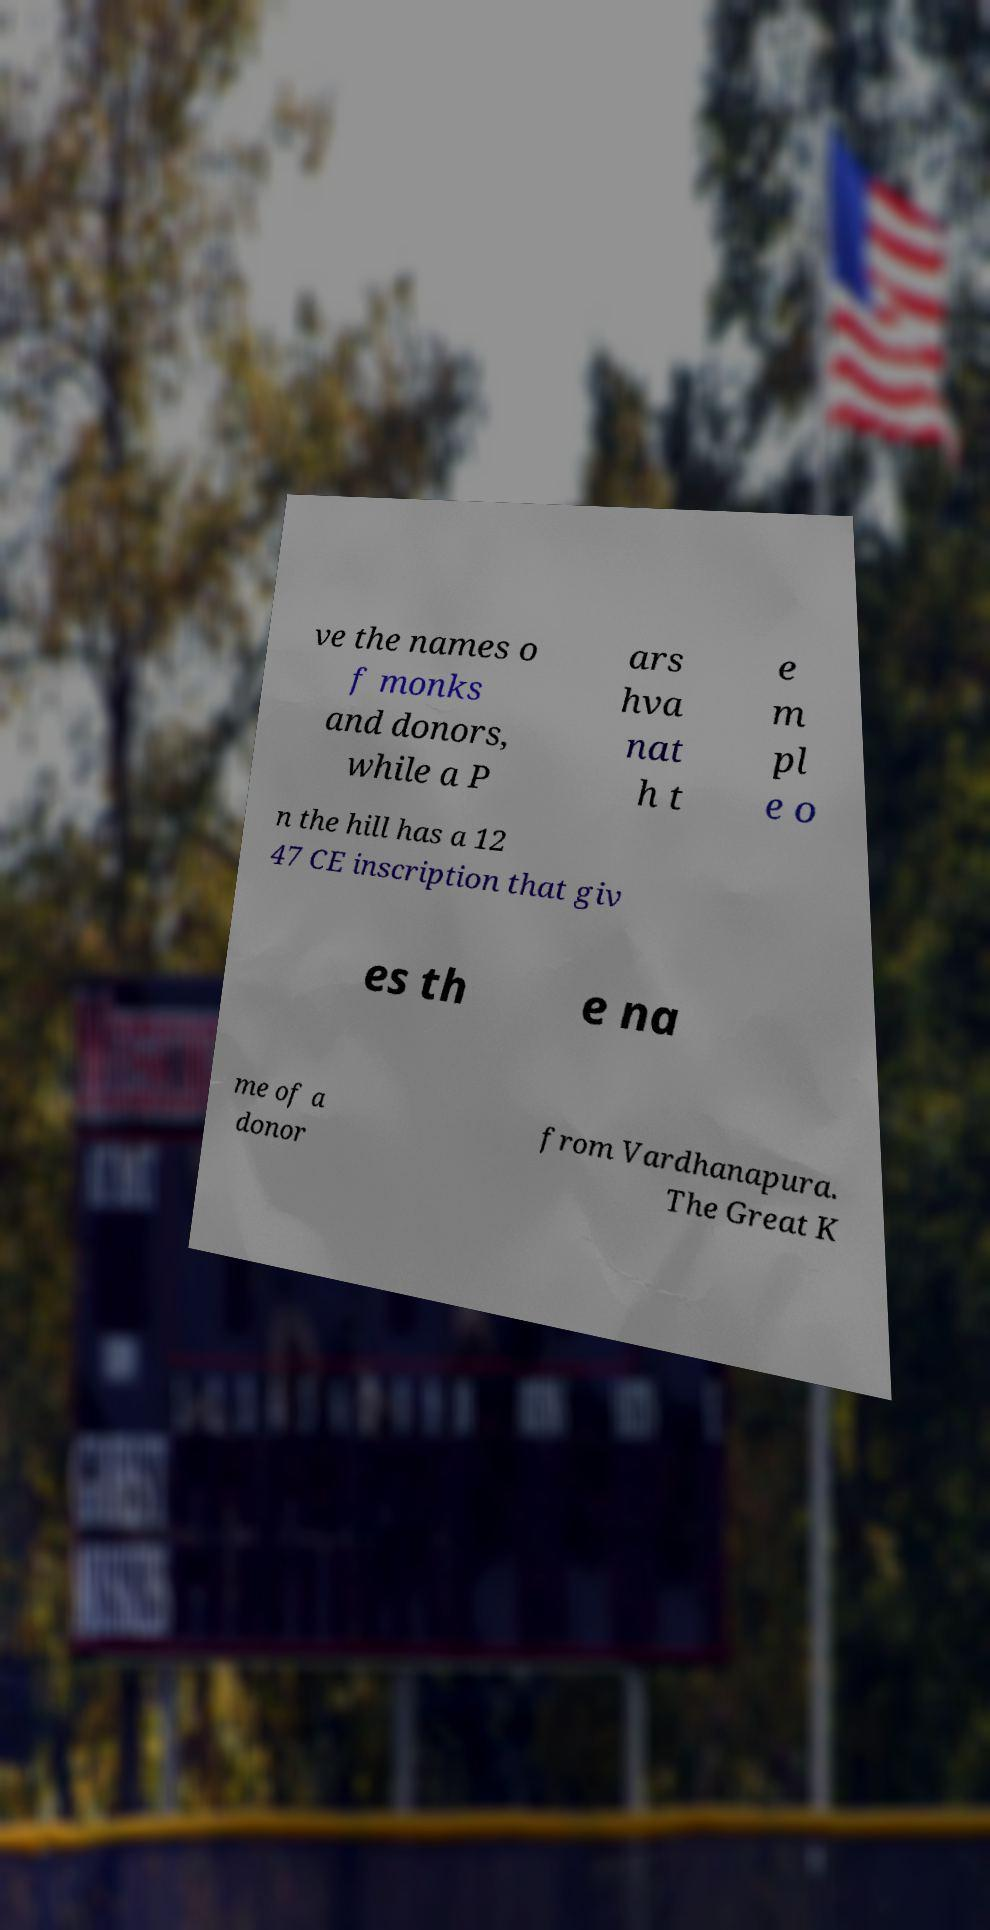Could you extract and type out the text from this image? ve the names o f monks and donors, while a P ars hva nat h t e m pl e o n the hill has a 12 47 CE inscription that giv es th e na me of a donor from Vardhanapura. The Great K 